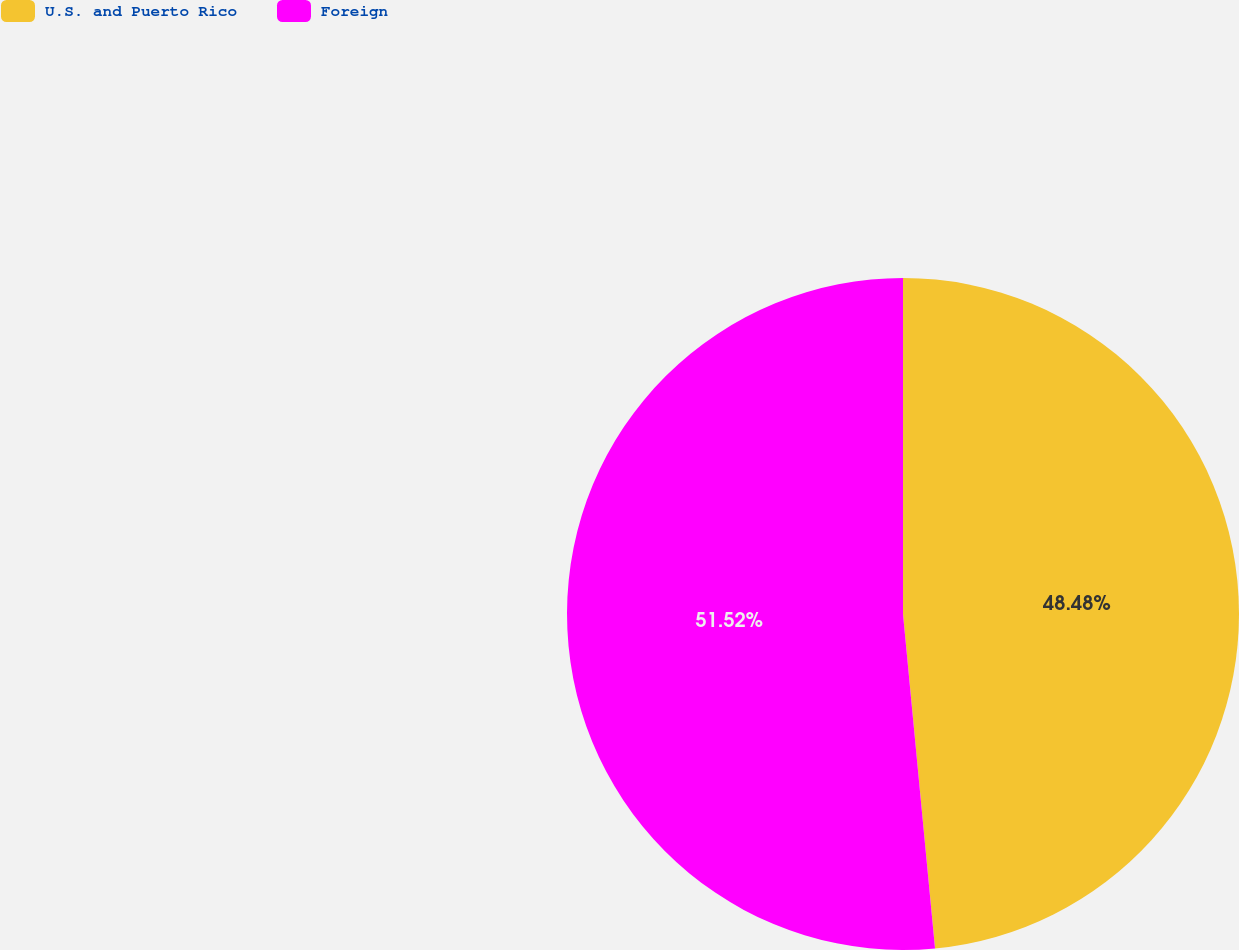Convert chart to OTSL. <chart><loc_0><loc_0><loc_500><loc_500><pie_chart><fcel>U.S. and Puerto Rico<fcel>Foreign<nl><fcel>48.48%<fcel>51.52%<nl></chart> 